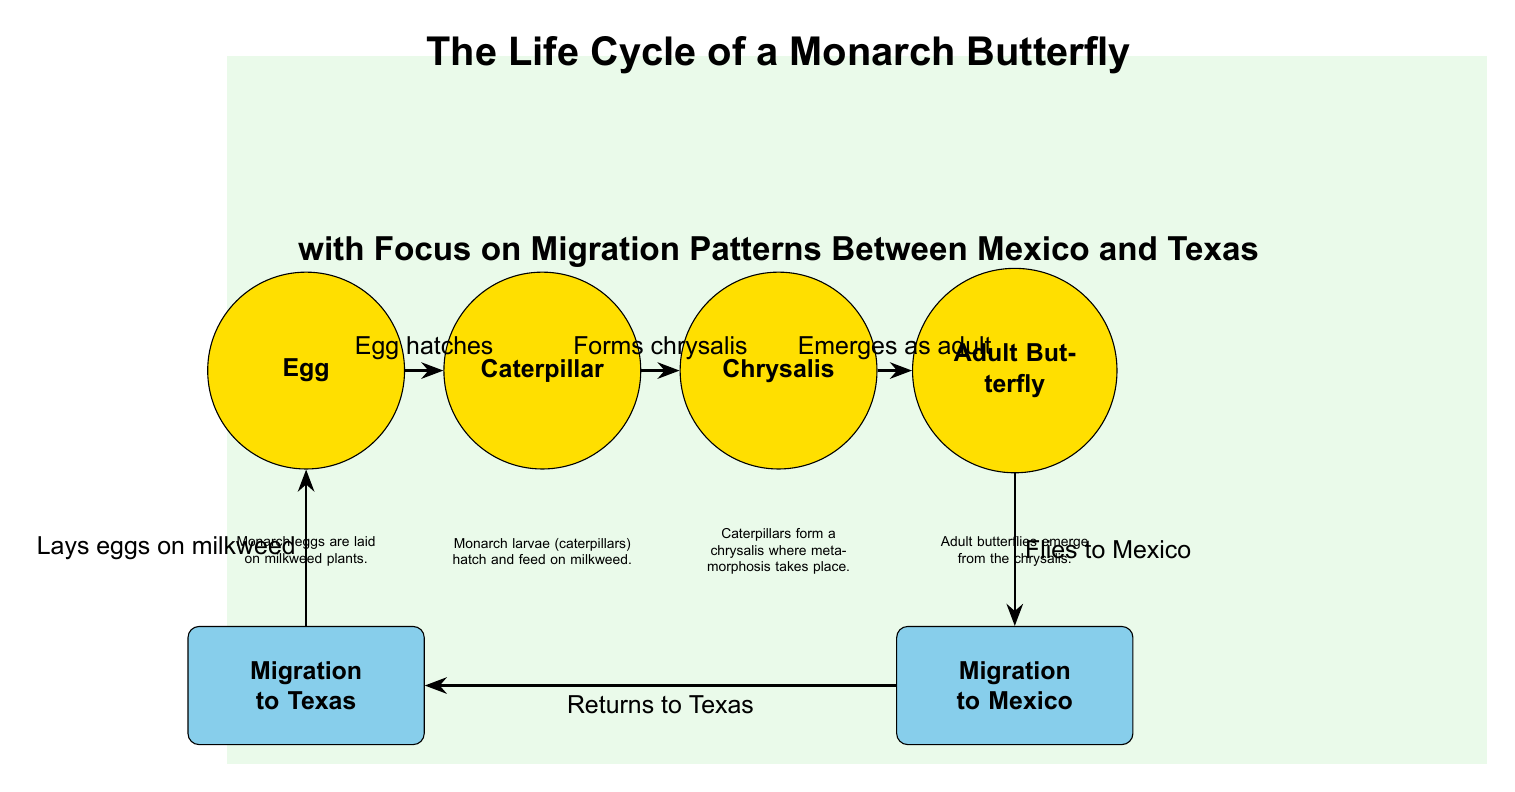What is the first stage in the Monarch butterfly life cycle? The diagram indicates that the first stage is labeled "Egg." This is the initial stage where Monarch eggs are laid on milkweed plants.
Answer: Egg How many stages are there in the life cycle of the Monarch butterfly? The diagram shows a total of four stages: Egg, Caterpillar, Chrysalis, and Adult Butterfly. Counting these stages gives the total number.
Answer: 4 What happens after the caterpillar stage? The diagram illustrates that after the caterpillar (larva) stage, it forms a chrysalis. This is the next step in the life cycle.
Answer: Forms chrysalis In which direction do adult butterflies migrate? The diagram specifies that adult butterflies fly to Mexico after emerging from the chrysalis. This shows the migration direction from Texas to Mexico.
Answer: To Mexico What do adult butterflies do when they return to Texas? According to the diagram, upon returning to Texas, adult butterflies lay eggs on milkweed. This indicates their reproductive behavior during migration.
Answer: Lays eggs on milkweed Which stage precedes the migration to Mexico? The diagram indicates that the adult butterfly stage precedes migration to Mexico. It’s specifically noted that adult butterflies migrate after they emerge.
Answer: Adult Butterfly During what stage do Monarch larvae feed? The diagram explains that during the caterpillar (larva) stage, they feed on milkweed, which is essential for their growth.
Answer: Caterpillar What does the chrysalis stage signify in the life cycle? The diagram points out that the chrysalis stage is where metamorphosis occurs, representing a transformation from caterpillar to adult butterfly.
Answer: Metamorphosis How do Monarch butterflies contribute to their lifecycle in Texas? The diagram shows that Monarch butterflies lay eggs on milkweed when they return to Texas, contributing to the next generation of Monarchs.
Answer: Lays eggs on milkweed 